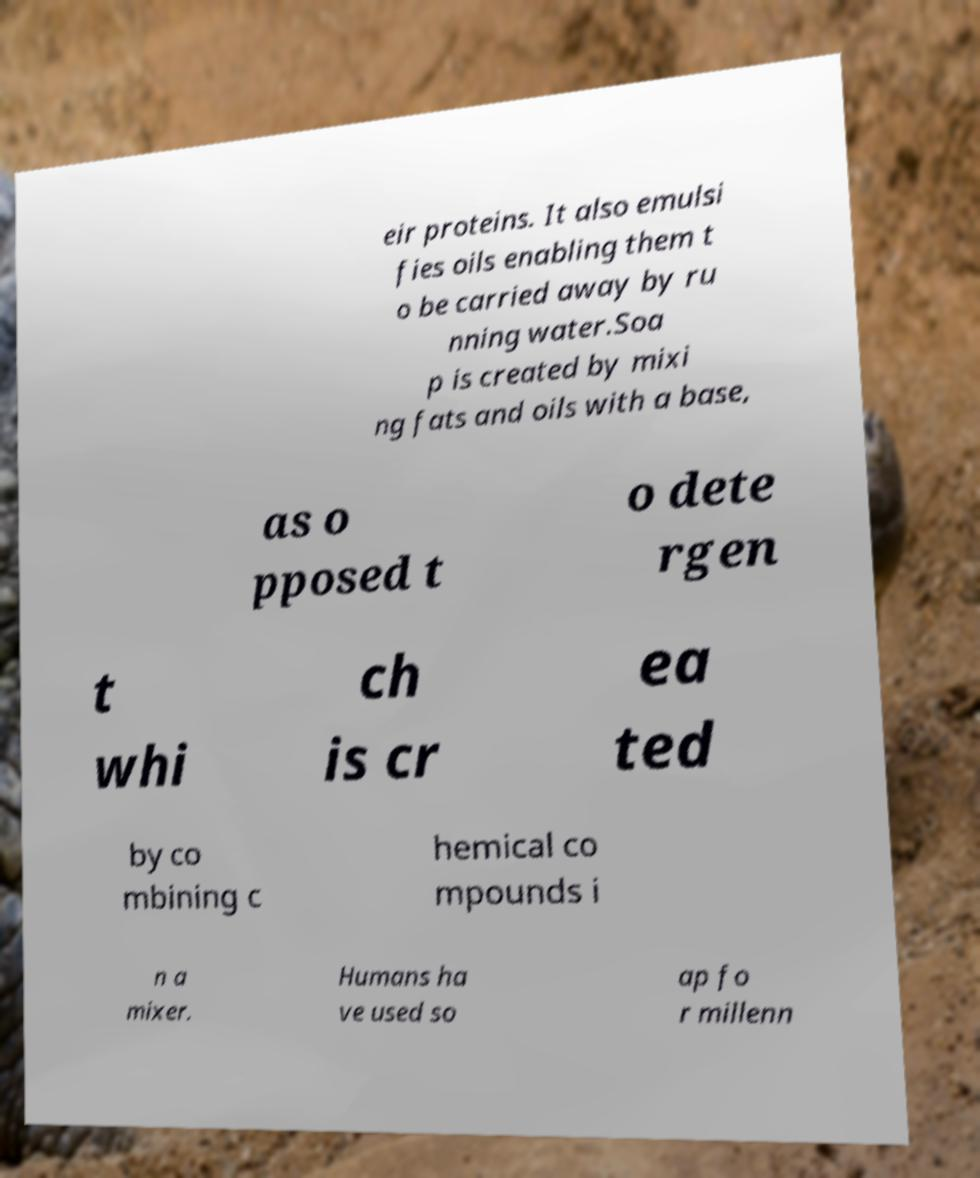I need the written content from this picture converted into text. Can you do that? eir proteins. It also emulsi fies oils enabling them t o be carried away by ru nning water.Soa p is created by mixi ng fats and oils with a base, as o pposed t o dete rgen t whi ch is cr ea ted by co mbining c hemical co mpounds i n a mixer. Humans ha ve used so ap fo r millenn 